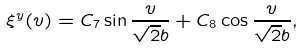Convert formula to latex. <formula><loc_0><loc_0><loc_500><loc_500>\xi ^ { y } ( v ) = C _ { 7 } \sin \frac { v } { \sqrt { 2 } b } + C _ { 8 } \cos \frac { v } { \sqrt { 2 } b } ,</formula> 